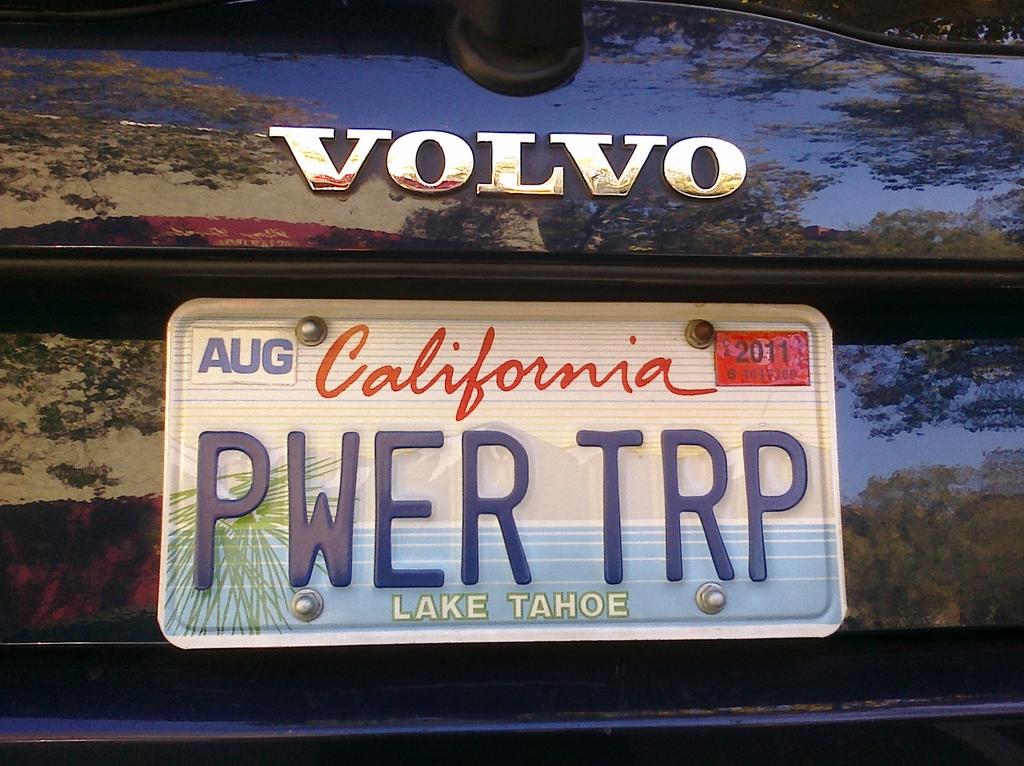What is the license plate tag name?
Your answer should be compact. Pwer trp. Is this car a volvo?
Your response must be concise. Yes. 